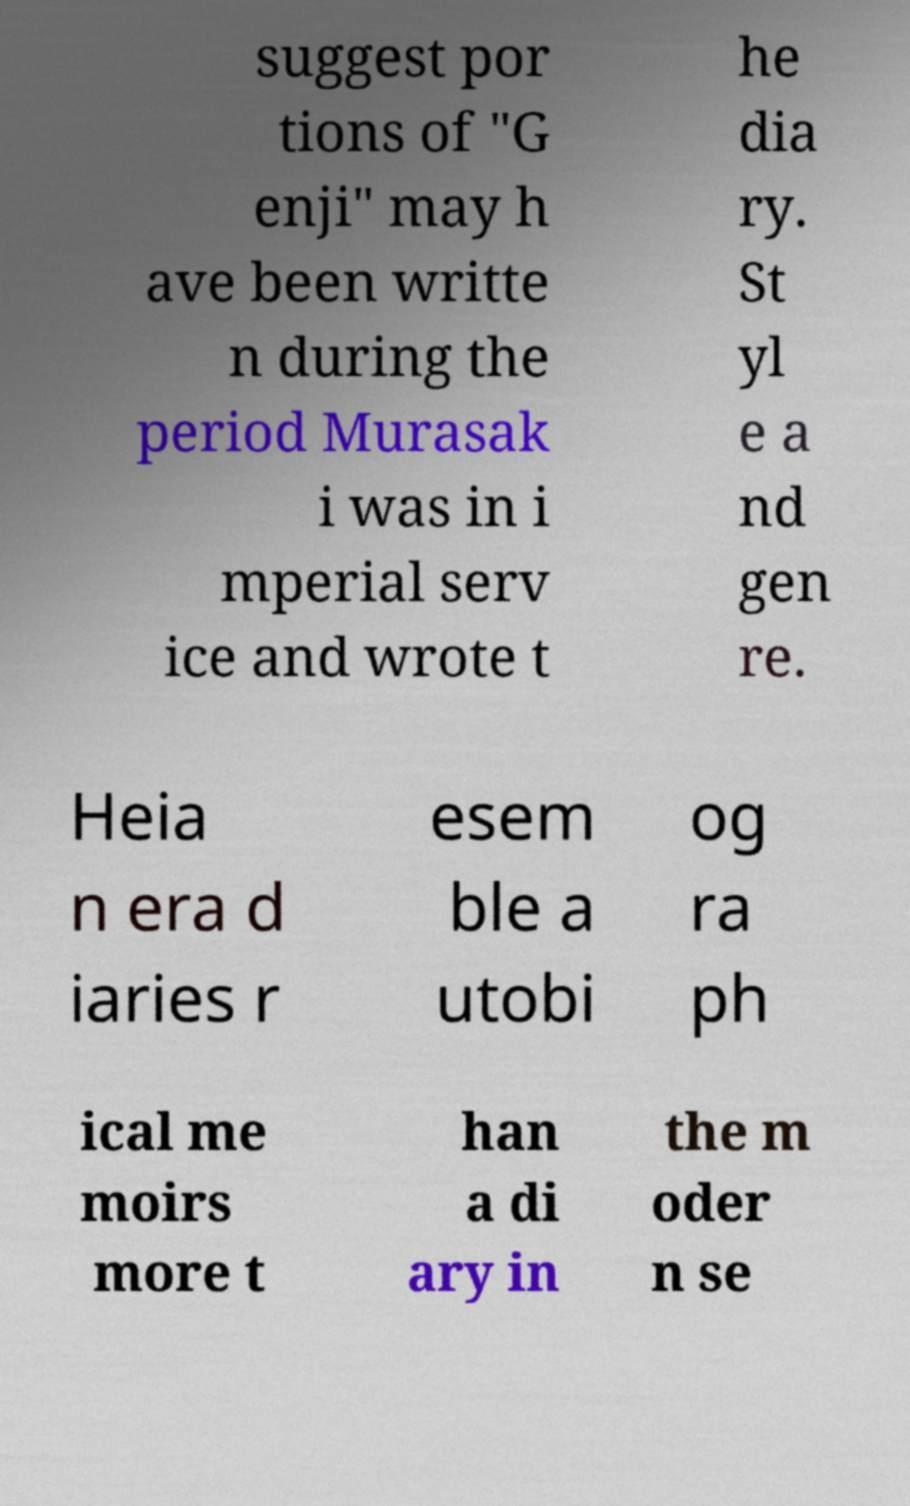Could you assist in decoding the text presented in this image and type it out clearly? suggest por tions of "G enji" may h ave been writte n during the period Murasak i was in i mperial serv ice and wrote t he dia ry. St yl e a nd gen re. Heia n era d iaries r esem ble a utobi og ra ph ical me moirs more t han a di ary in the m oder n se 